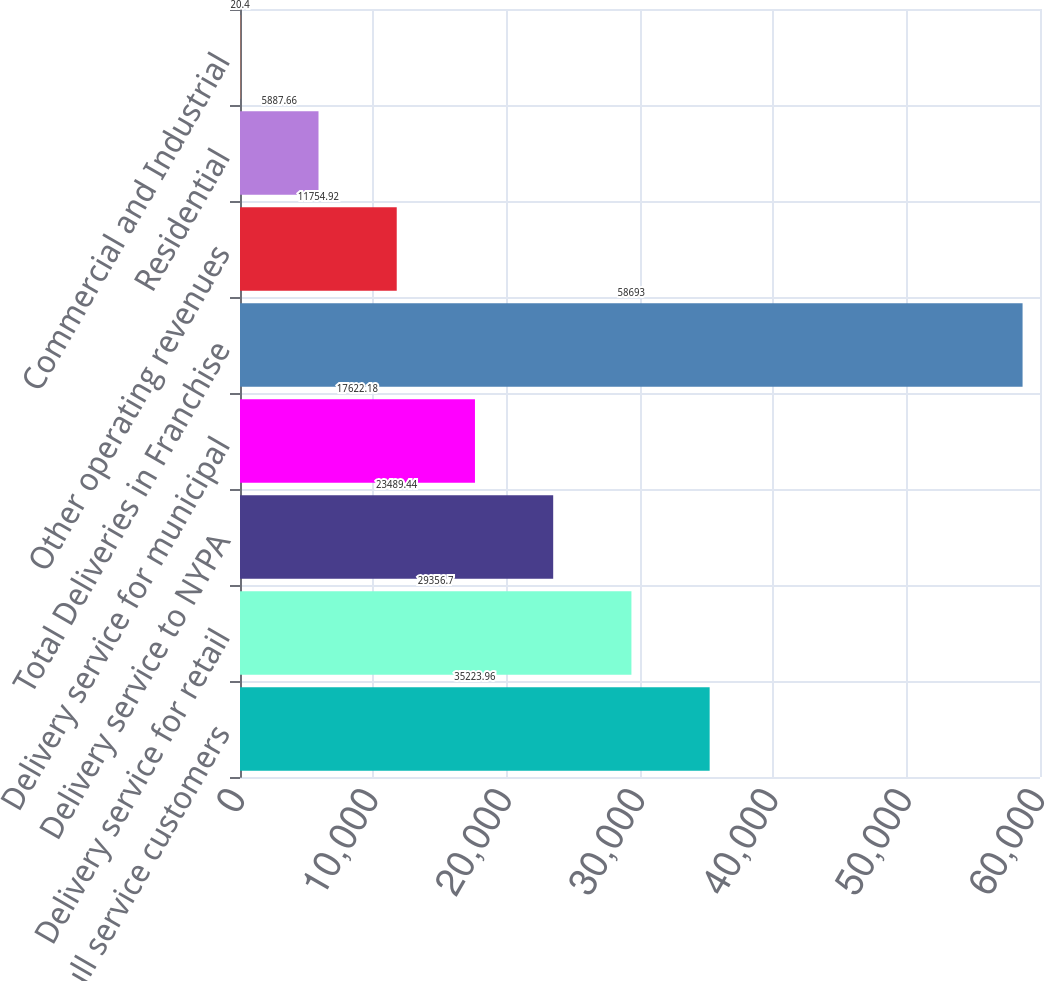Convert chart to OTSL. <chart><loc_0><loc_0><loc_500><loc_500><bar_chart><fcel>CECONY full service customers<fcel>Delivery service for retail<fcel>Delivery service to NYPA<fcel>Delivery service for municipal<fcel>Total Deliveries in Franchise<fcel>Other operating revenues<fcel>Residential<fcel>Commercial and Industrial<nl><fcel>35224<fcel>29356.7<fcel>23489.4<fcel>17622.2<fcel>58693<fcel>11754.9<fcel>5887.66<fcel>20.4<nl></chart> 